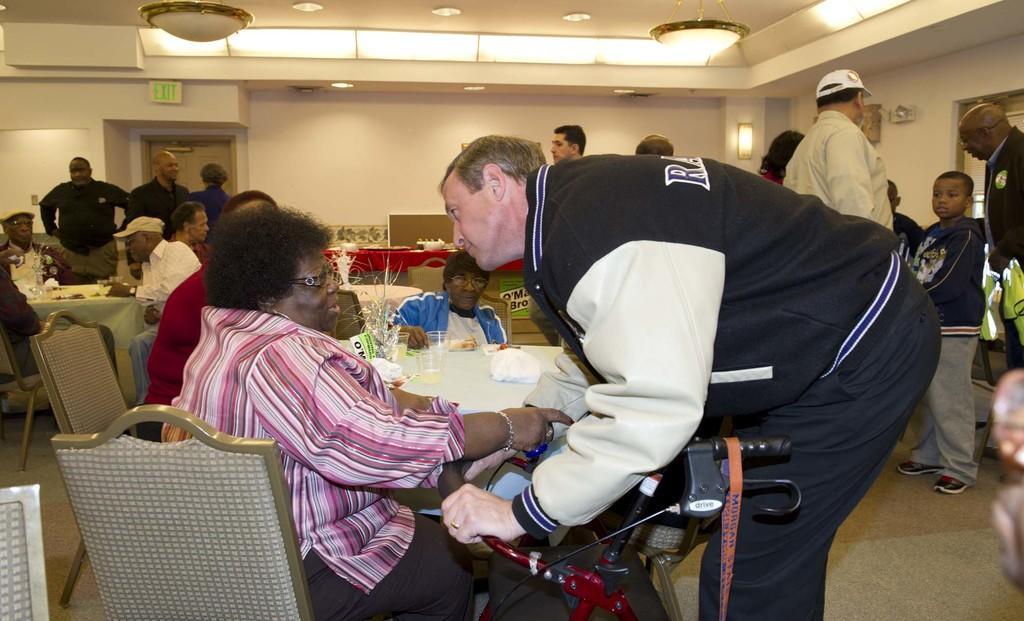In one or two sentences, can you explain what this image depicts? This picture is of inside the room. In the foreground we can see a Man standing and bending towards a woman sitting on the chair. In the center there is a table, on the top of which glasses are placed. On the left there are group of persons sitting on the chairs. On the right there are group of people standing. In the background we can see a door, a wall and group of people standing. 